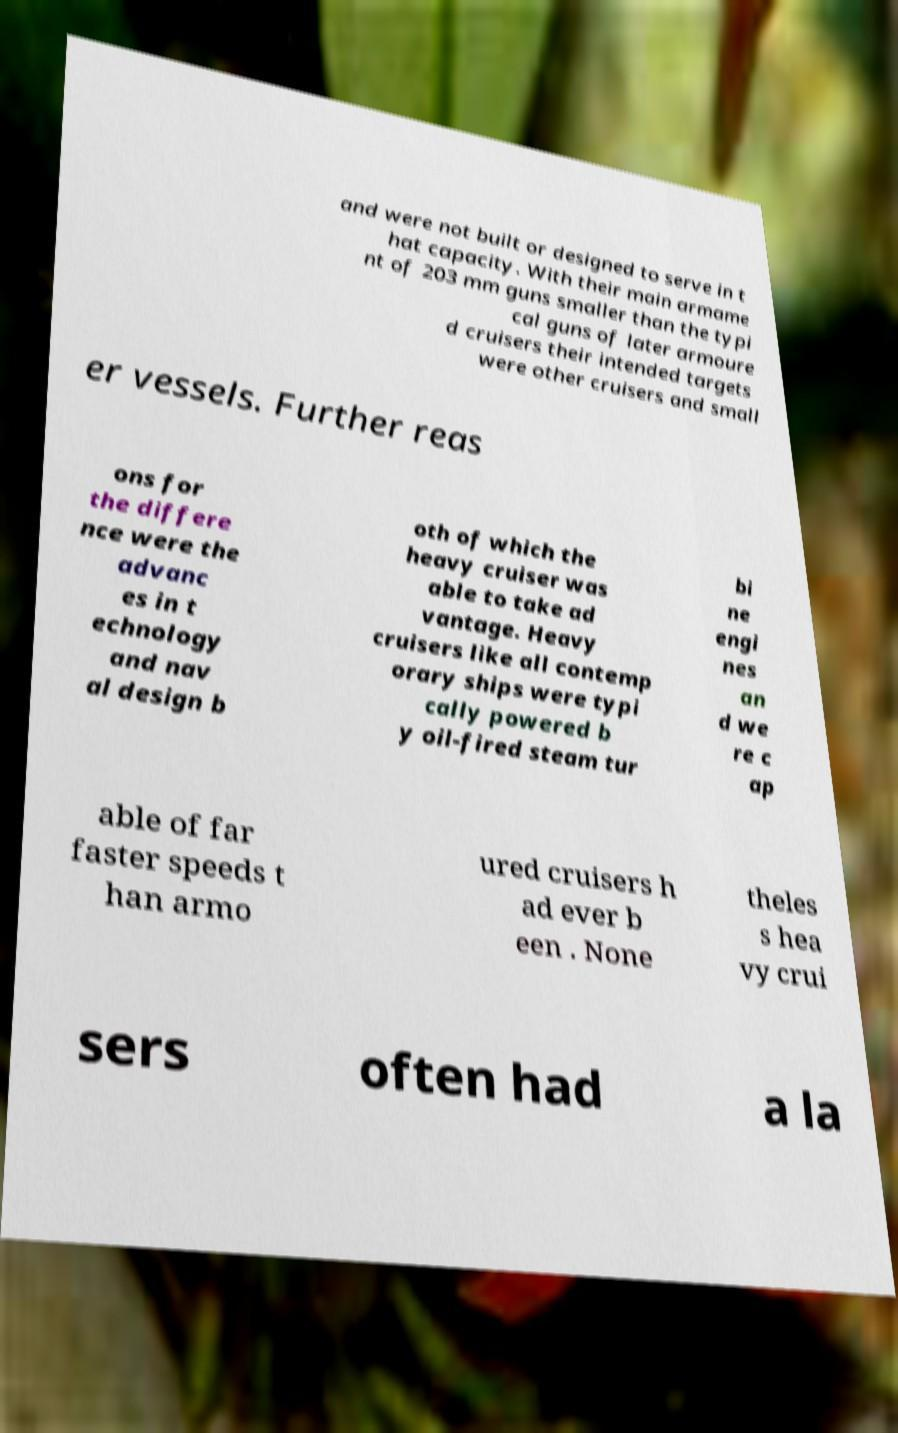Please read and relay the text visible in this image. What does it say? and were not built or designed to serve in t hat capacity. With their main armame nt of 203 mm guns smaller than the typi cal guns of later armoure d cruisers their intended targets were other cruisers and small er vessels. Further reas ons for the differe nce were the advanc es in t echnology and nav al design b oth of which the heavy cruiser was able to take ad vantage. Heavy cruisers like all contemp orary ships were typi cally powered b y oil-fired steam tur bi ne engi nes an d we re c ap able of far faster speeds t han armo ured cruisers h ad ever b een . None theles s hea vy crui sers often had a la 